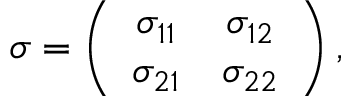<formula> <loc_0><loc_0><loc_500><loc_500>\begin{array} { r } { \sigma = \left ( \begin{array} { c c } { \sigma _ { 1 1 } } & { \sigma _ { 1 2 } } \\ { \sigma _ { 2 1 } } & { \sigma _ { 2 2 } } \end{array} \right ) , } \end{array}</formula> 